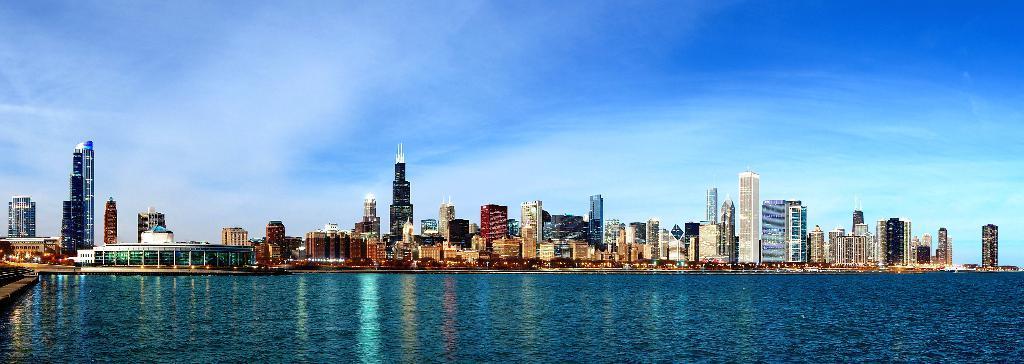How would you summarize this image in a sentence or two? In this image we can see few buildings, water in front of the buildings and the sky in the background. 